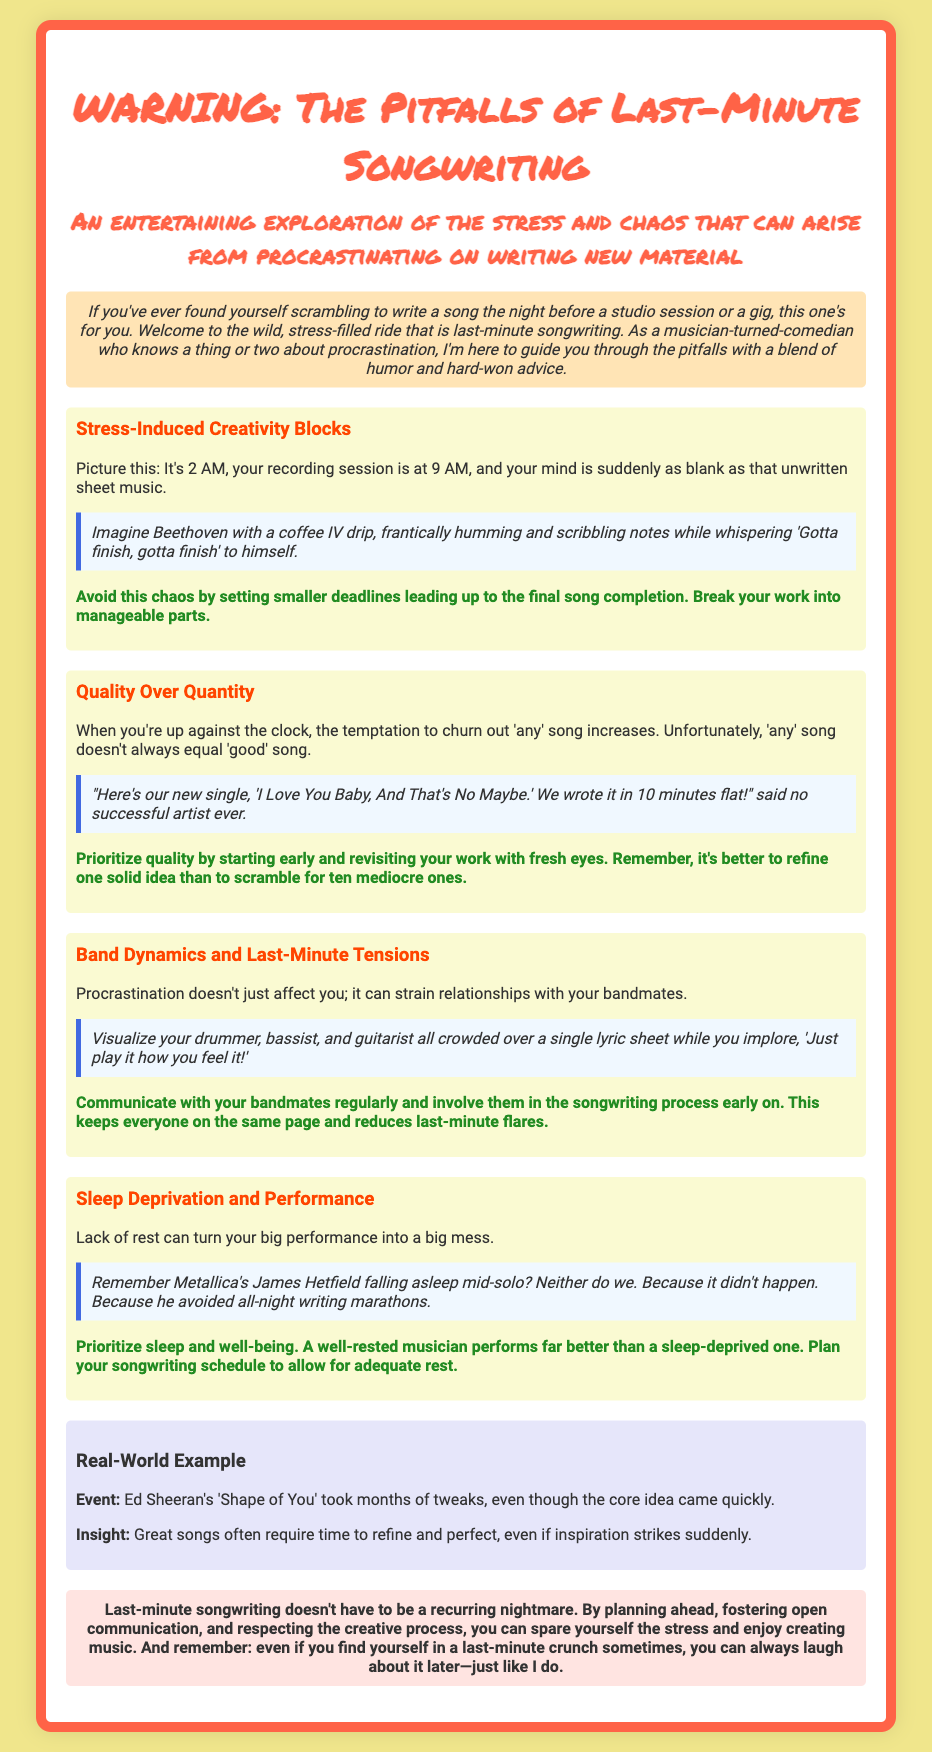What is the title of the warning label? The title is prominently displayed as the main heading of the document.
Answer: WARNING: The Pitfalls of Last-Minute Songwriting How many sections are there in the document? The document includes multiple sections, each focusing on different pitfalls of last-minute songwriting.
Answer: Four What time is mentioned for the recording session? The document specifically mentions the time of the recording session related to last-minute songwriting.
Answer: 9 AM Who is referred to as an example of managing sleep deprivation? This individual is mentioned in relation to avoiding all-night writing marathons and performing well-rested.
Answer: James Hetfield What does the scenario for stress-induced creativity blocks illustrate? The scenario conveys a humorous image of a famous composer under pressure during late-night songwriting.
Answer: Beethoven with a coffee IV drip What advice is given for avoiding last-minute chaos in songwriting? The advice aims to promote better time management and song development.
Answer: Set smaller deadlines leading up to the final song completion What song by Ed Sheeran is used as a real-world example? This song is referenced to highlight the importance of refining music over time.
Answer: Shape of You What is emphasized as more important when songwriting under time pressure? The document stresses the significance of quality over merely producing more songs.
Answer: Quality 